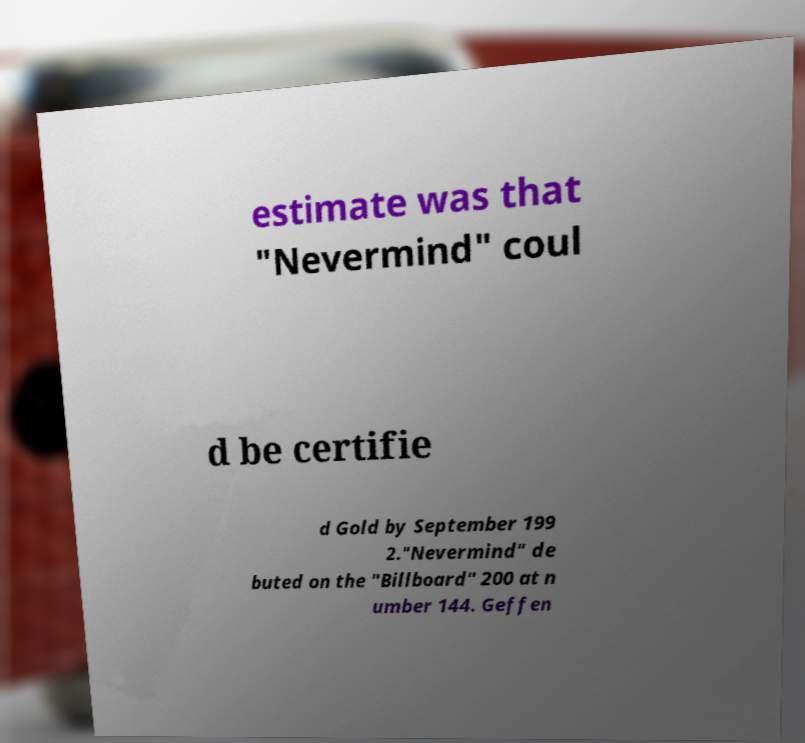Please identify and transcribe the text found in this image. estimate was that "Nevermind" coul d be certifie d Gold by September 199 2."Nevermind" de buted on the "Billboard" 200 at n umber 144. Geffen 